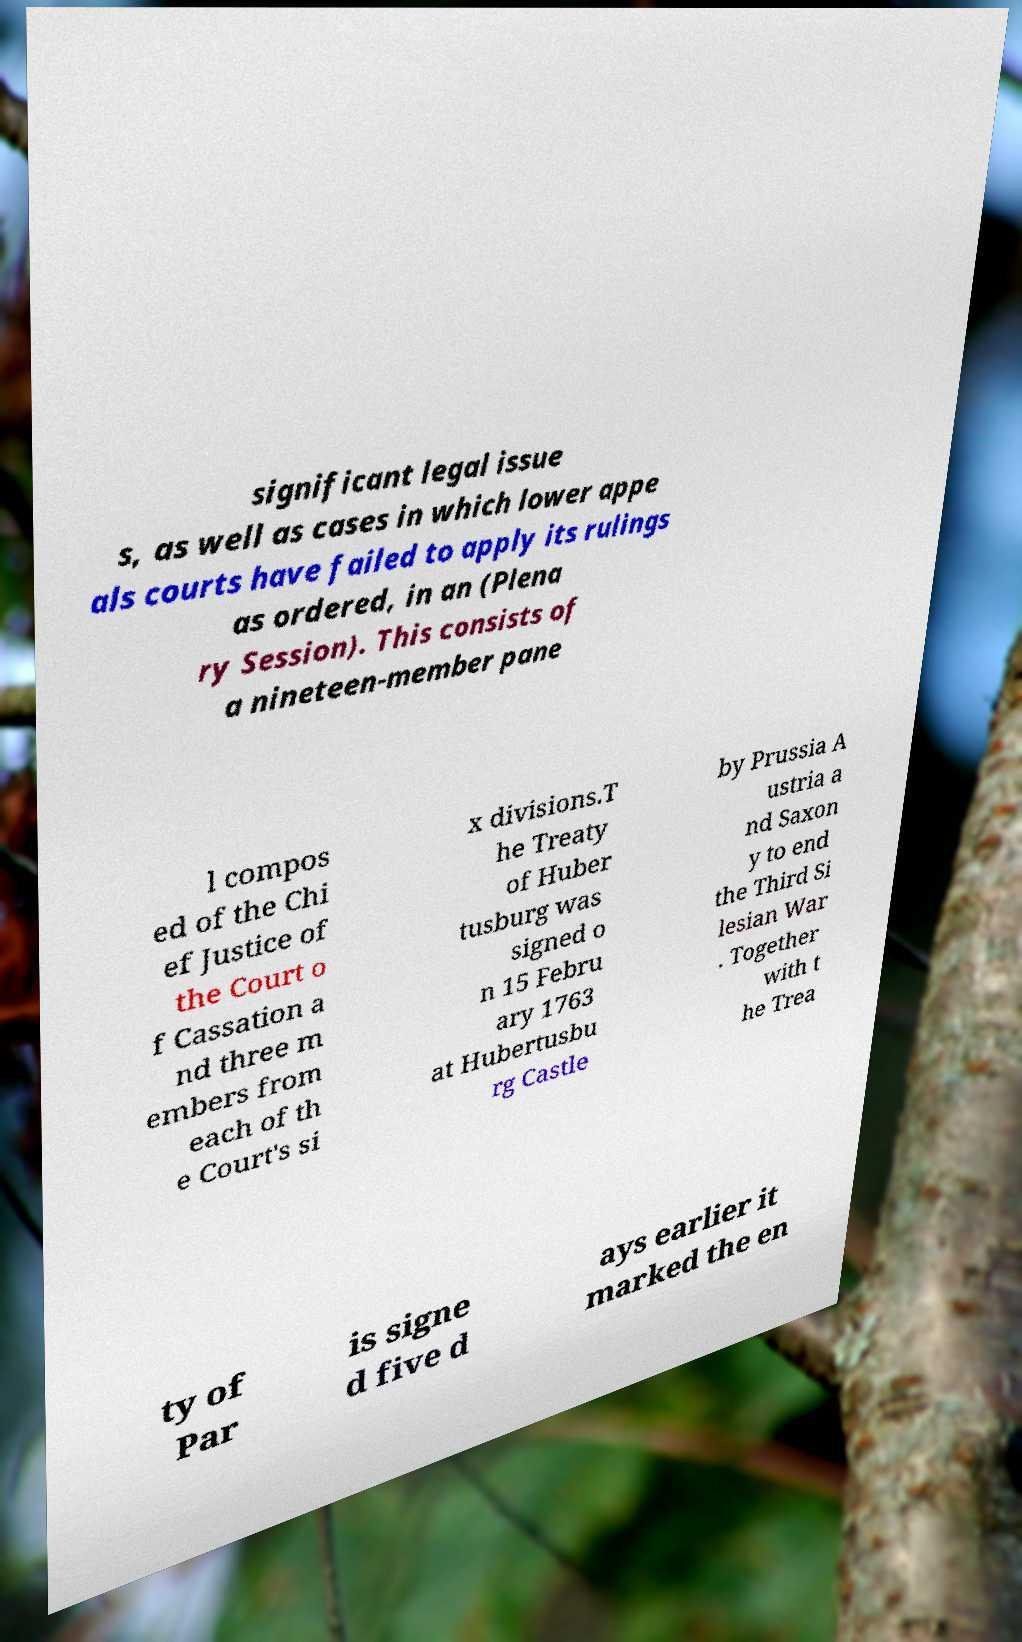For documentation purposes, I need the text within this image transcribed. Could you provide that? significant legal issue s, as well as cases in which lower appe als courts have failed to apply its rulings as ordered, in an (Plena ry Session). This consists of a nineteen-member pane l compos ed of the Chi ef Justice of the Court o f Cassation a nd three m embers from each of th e Court's si x divisions.T he Treaty of Huber tusburg was signed o n 15 Febru ary 1763 at Hubertusbu rg Castle by Prussia A ustria a nd Saxon y to end the Third Si lesian War . Together with t he Trea ty of Par is signe d five d ays earlier it marked the en 